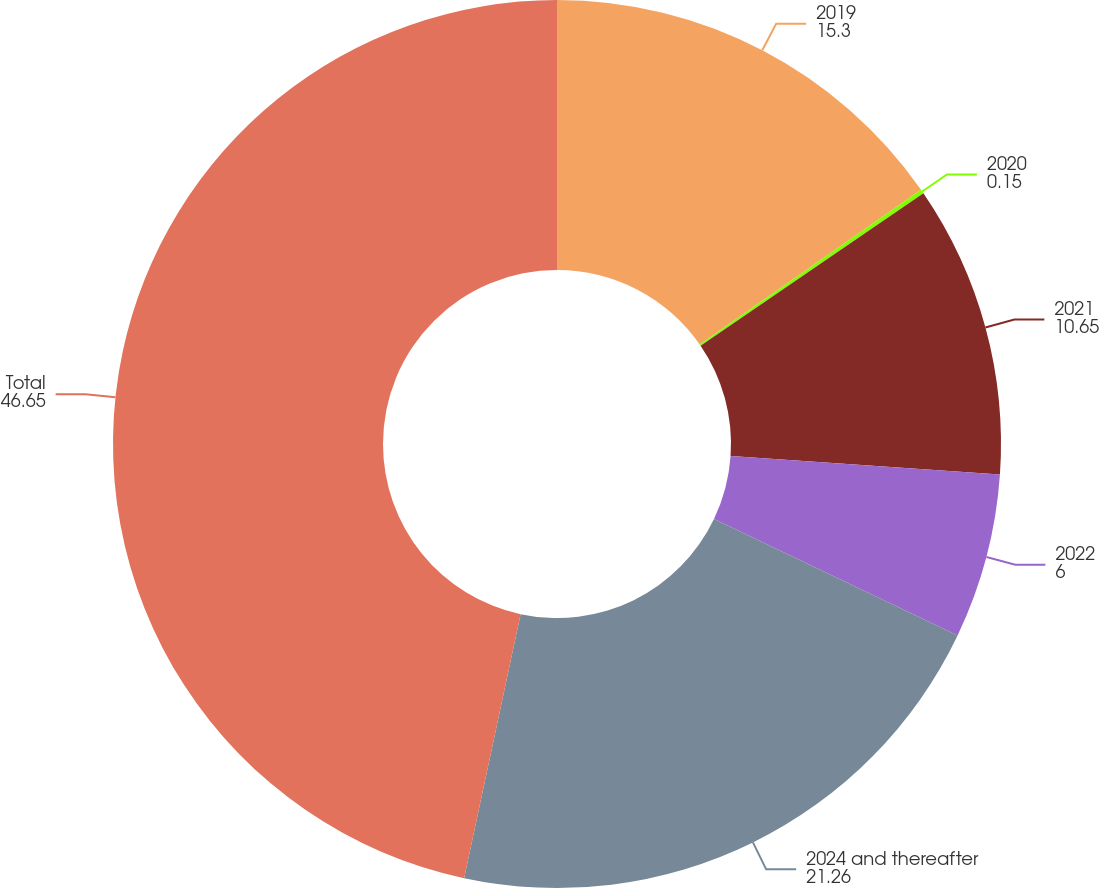Convert chart. <chart><loc_0><loc_0><loc_500><loc_500><pie_chart><fcel>2019<fcel>2020<fcel>2021<fcel>2022<fcel>2024 and thereafter<fcel>Total<nl><fcel>15.3%<fcel>0.15%<fcel>10.65%<fcel>6.0%<fcel>21.26%<fcel>46.65%<nl></chart> 